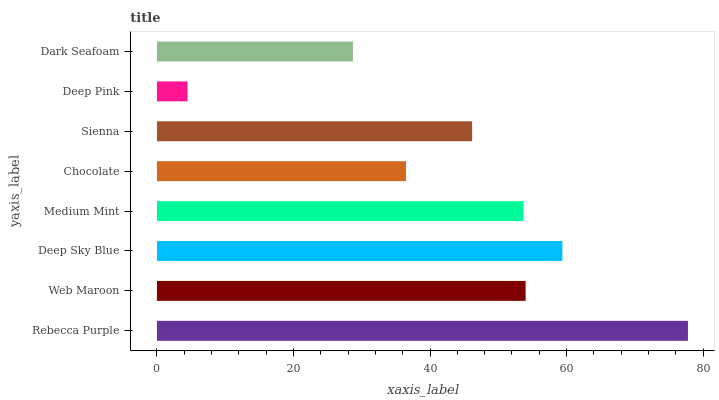Is Deep Pink the minimum?
Answer yes or no. Yes. Is Rebecca Purple the maximum?
Answer yes or no. Yes. Is Web Maroon the minimum?
Answer yes or no. No. Is Web Maroon the maximum?
Answer yes or no. No. Is Rebecca Purple greater than Web Maroon?
Answer yes or no. Yes. Is Web Maroon less than Rebecca Purple?
Answer yes or no. Yes. Is Web Maroon greater than Rebecca Purple?
Answer yes or no. No. Is Rebecca Purple less than Web Maroon?
Answer yes or no. No. Is Medium Mint the high median?
Answer yes or no. Yes. Is Sienna the low median?
Answer yes or no. Yes. Is Chocolate the high median?
Answer yes or no. No. Is Deep Sky Blue the low median?
Answer yes or no. No. 